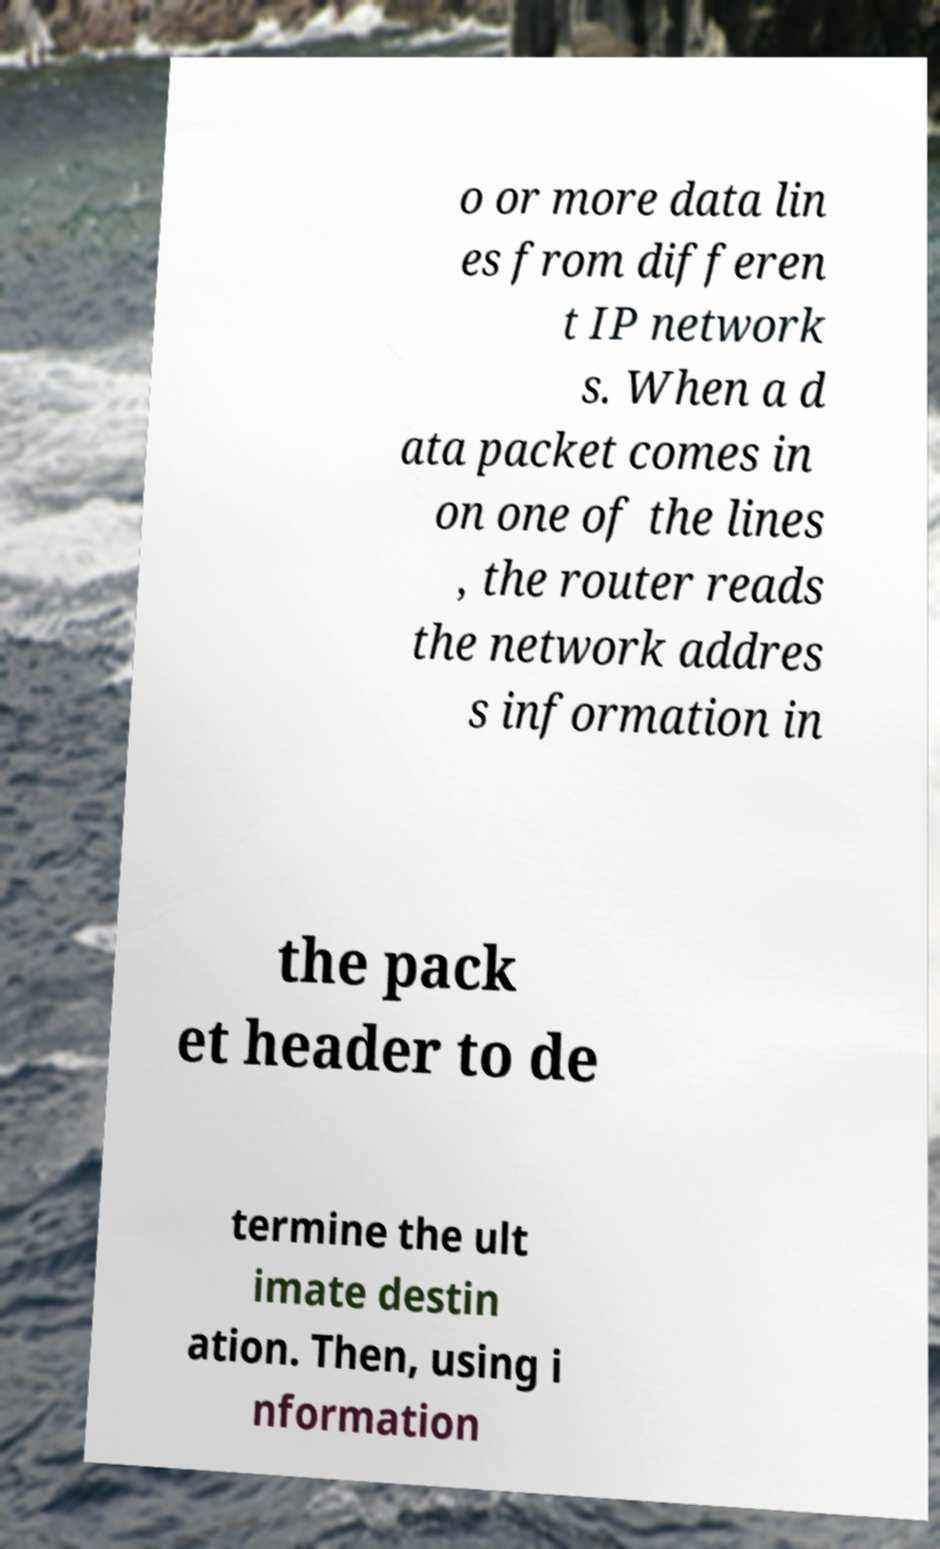Could you extract and type out the text from this image? o or more data lin es from differen t IP network s. When a d ata packet comes in on one of the lines , the router reads the network addres s information in the pack et header to de termine the ult imate destin ation. Then, using i nformation 